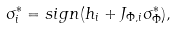Convert formula to latex. <formula><loc_0><loc_0><loc_500><loc_500>\sigma _ { i } ^ { * } = s i g n ( h _ { i } + J _ { \Phi , i } \sigma _ { \Phi } ^ { * } ) ,</formula> 